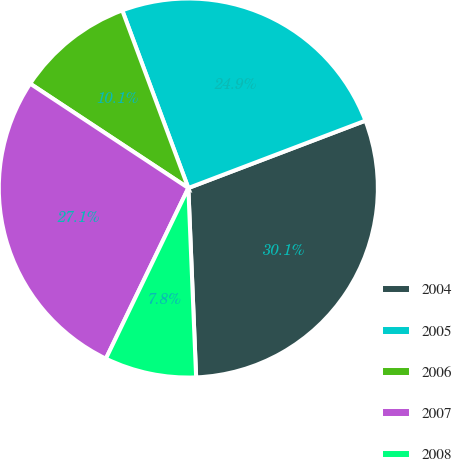<chart> <loc_0><loc_0><loc_500><loc_500><pie_chart><fcel>2004<fcel>2005<fcel>2006<fcel>2007<fcel>2008<nl><fcel>30.13%<fcel>24.88%<fcel>10.05%<fcel>27.12%<fcel>7.82%<nl></chart> 